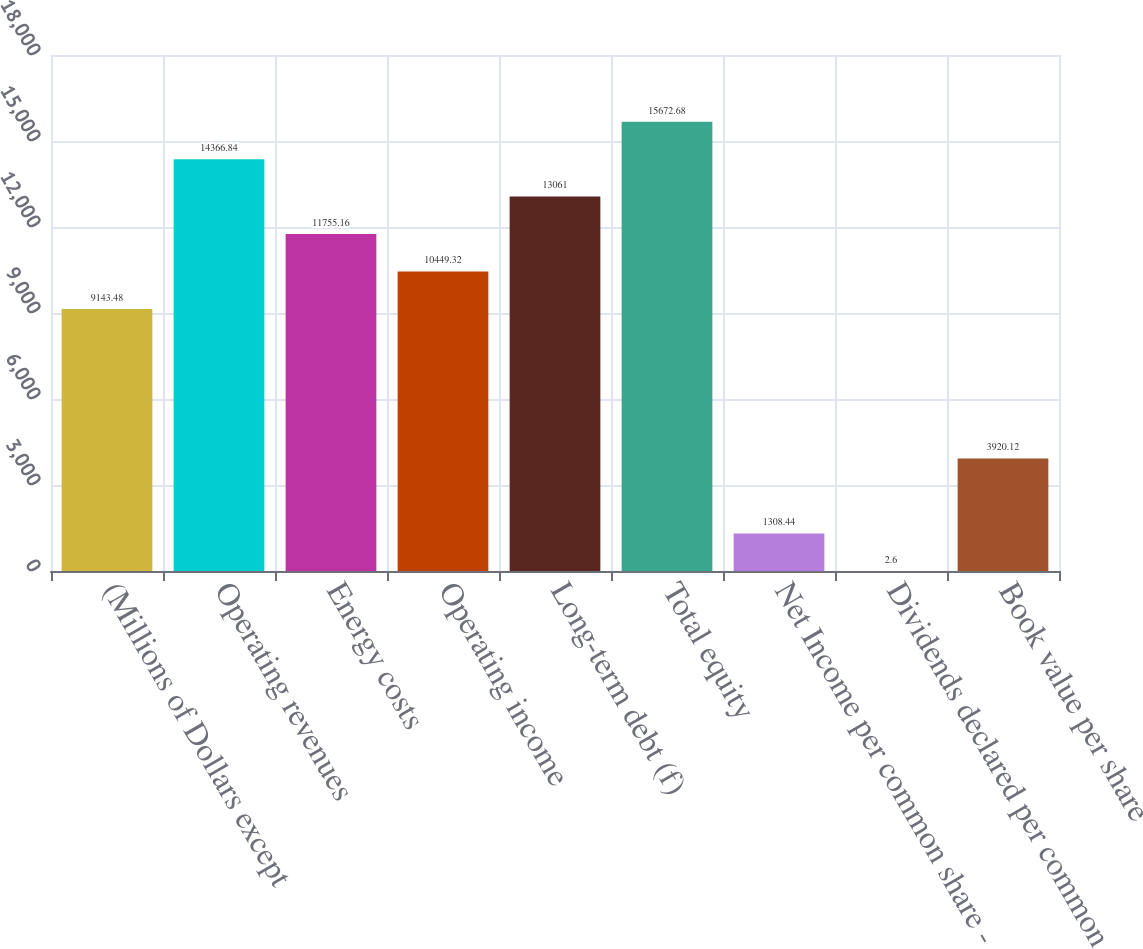Convert chart. <chart><loc_0><loc_0><loc_500><loc_500><bar_chart><fcel>(Millions of Dollars except<fcel>Operating revenues<fcel>Energy costs<fcel>Operating income<fcel>Long-term debt (f)<fcel>Total equity<fcel>Net Income per common share -<fcel>Dividends declared per common<fcel>Book value per share<nl><fcel>9143.48<fcel>14366.8<fcel>11755.2<fcel>10449.3<fcel>13061<fcel>15672.7<fcel>1308.44<fcel>2.6<fcel>3920.12<nl></chart> 